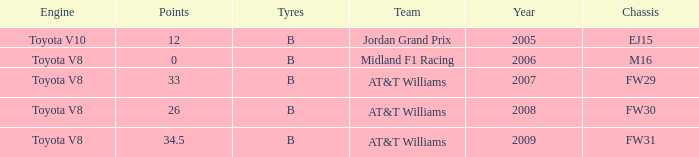Can you give me this table as a dict? {'header': ['Engine', 'Points', 'Tyres', 'Team', 'Year', 'Chassis'], 'rows': [['Toyota V10', '12', 'B', 'Jordan Grand Prix', '2005', 'EJ15'], ['Toyota V8', '0', 'B', 'Midland F1 Racing', '2006', 'M16'], ['Toyota V8', '33', 'B', 'AT&T Williams', '2007', 'FW29'], ['Toyota V8', '26', 'B', 'AT&T Williams', '2008', 'FW30'], ['Toyota V8', '34.5', 'B', 'AT&T Williams', '2009', 'FW31']]} What is the low point total after 2006 with an m16 chassis? None. 